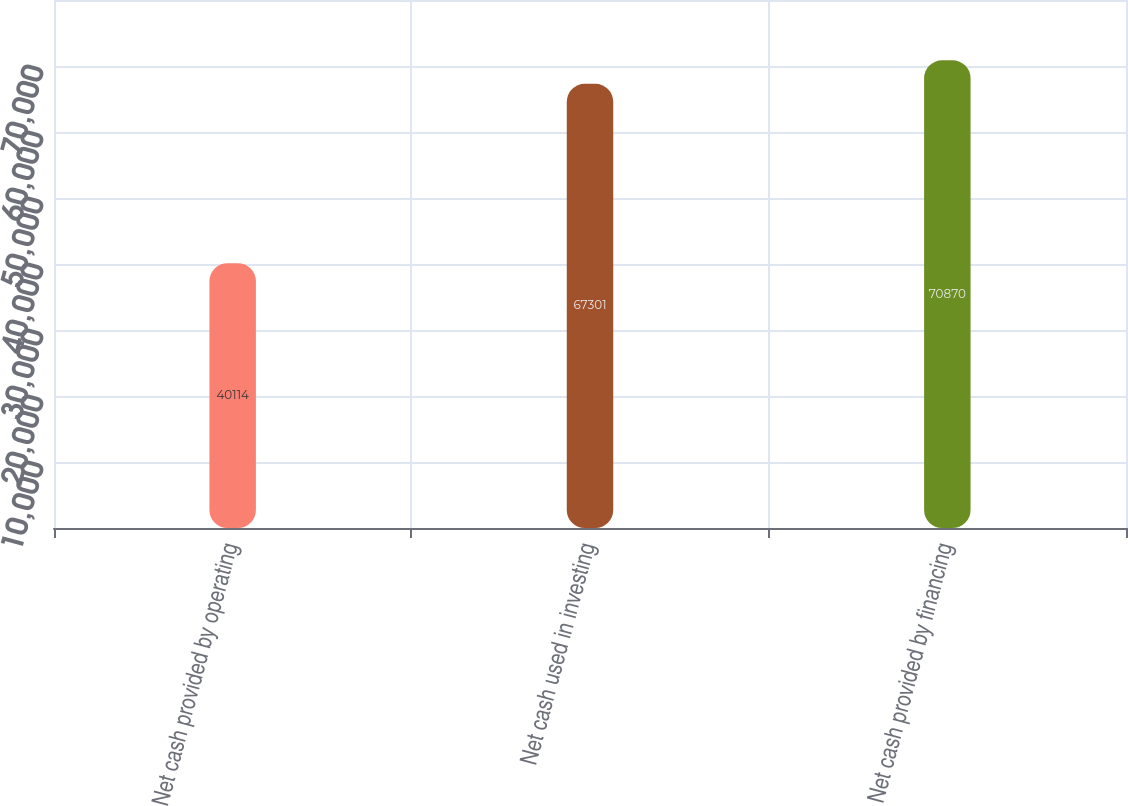Convert chart to OTSL. <chart><loc_0><loc_0><loc_500><loc_500><bar_chart><fcel>Net cash provided by operating<fcel>Net cash used in investing<fcel>Net cash provided by financing<nl><fcel>40114<fcel>67301<fcel>70870<nl></chart> 